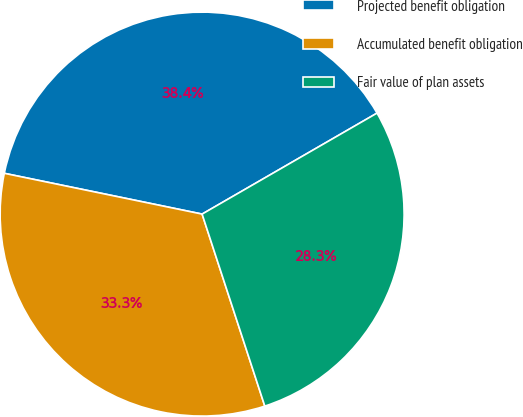<chart> <loc_0><loc_0><loc_500><loc_500><pie_chart><fcel>Projected benefit obligation<fcel>Accumulated benefit obligation<fcel>Fair value of plan assets<nl><fcel>38.43%<fcel>33.26%<fcel>28.31%<nl></chart> 